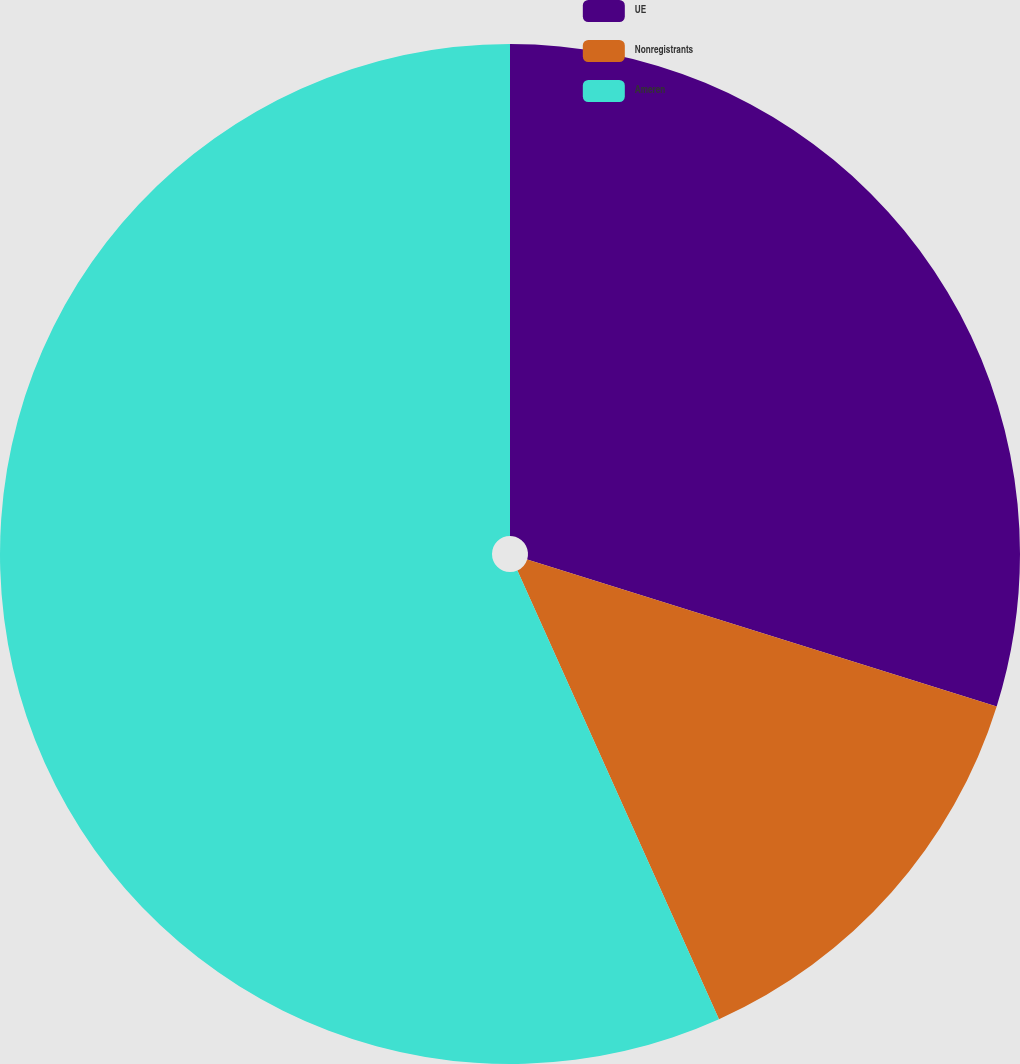Convert chart to OTSL. <chart><loc_0><loc_0><loc_500><loc_500><pie_chart><fcel>UE<fcel>Nonregistrants<fcel>Ameren<nl><fcel>29.83%<fcel>13.45%<fcel>56.72%<nl></chart> 